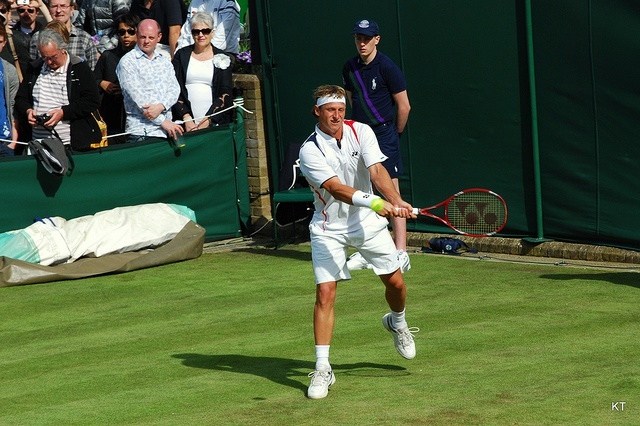Describe the objects in this image and their specific colors. I can see people in black, white, darkgray, and gray tones, people in black, lightgray, gray, and darkgray tones, people in black, navy, tan, and brown tones, people in black, white, tan, and darkgray tones, and people in black, lightgray, lightblue, and lightpink tones in this image. 